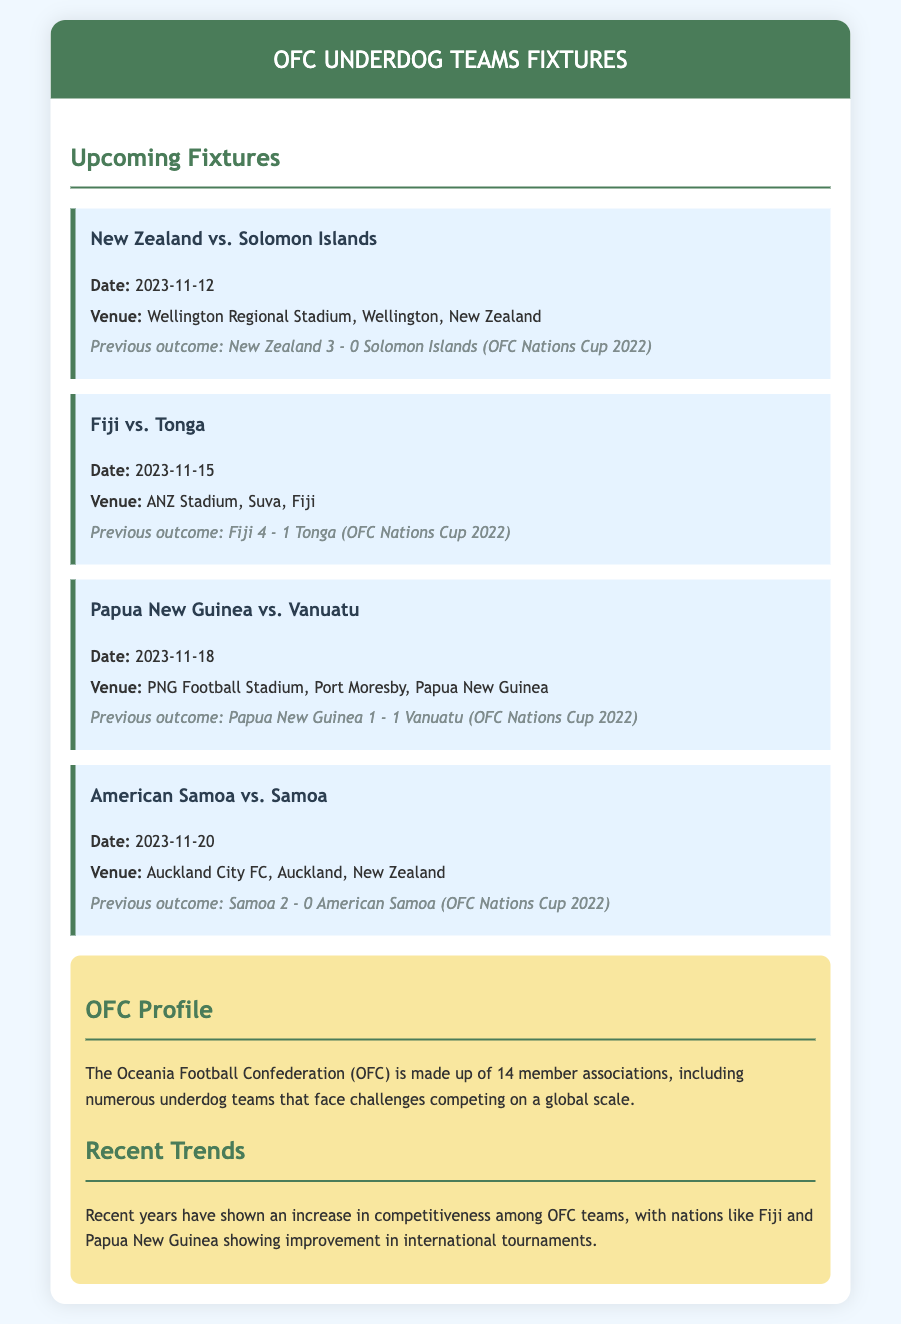What is the date of the match between New Zealand and Solomon Islands? The date is found under the fixture details for New Zealand vs. Solomon Islands.
Answer: 2023-11-12 Where is the Fiji vs. Tonga match being held? The venue is specified in the details for the Fiji vs. Tonga match.
Answer: ANZ Stadium, Suva, Fiji What was the previous outcome of the Papua New Guinea vs. Vanuatu match? The previous outcome is noted in the fixture details for Papua New Guinea vs. Vanuatu.
Answer: 1 - 1 Who plays against American Samoa on November 20, 2023? This information is on the fixture details for the match on that date.
Answer: Samoa What is the historical context mentioned in the document about OFC? The historical context discusses the challenges faced by OFC teams in global competitions, as mentioned in the document.
Answer: Made up of 14 member associations, challenges competing on a global scale Which two teams are noted for showing improvement in international tournaments? This is part of the recent trends section in the document, reflecting competitive growth.
Answer: Fiji and Papua New Guinea What is the overall background color of the document? The background color for the body of the document is specified in the CSS.
Answer: Light blue How many matches are listed in the upcoming fixtures? The number of fixtures can be counted based on the number of presentations in the document.
Answer: Four 